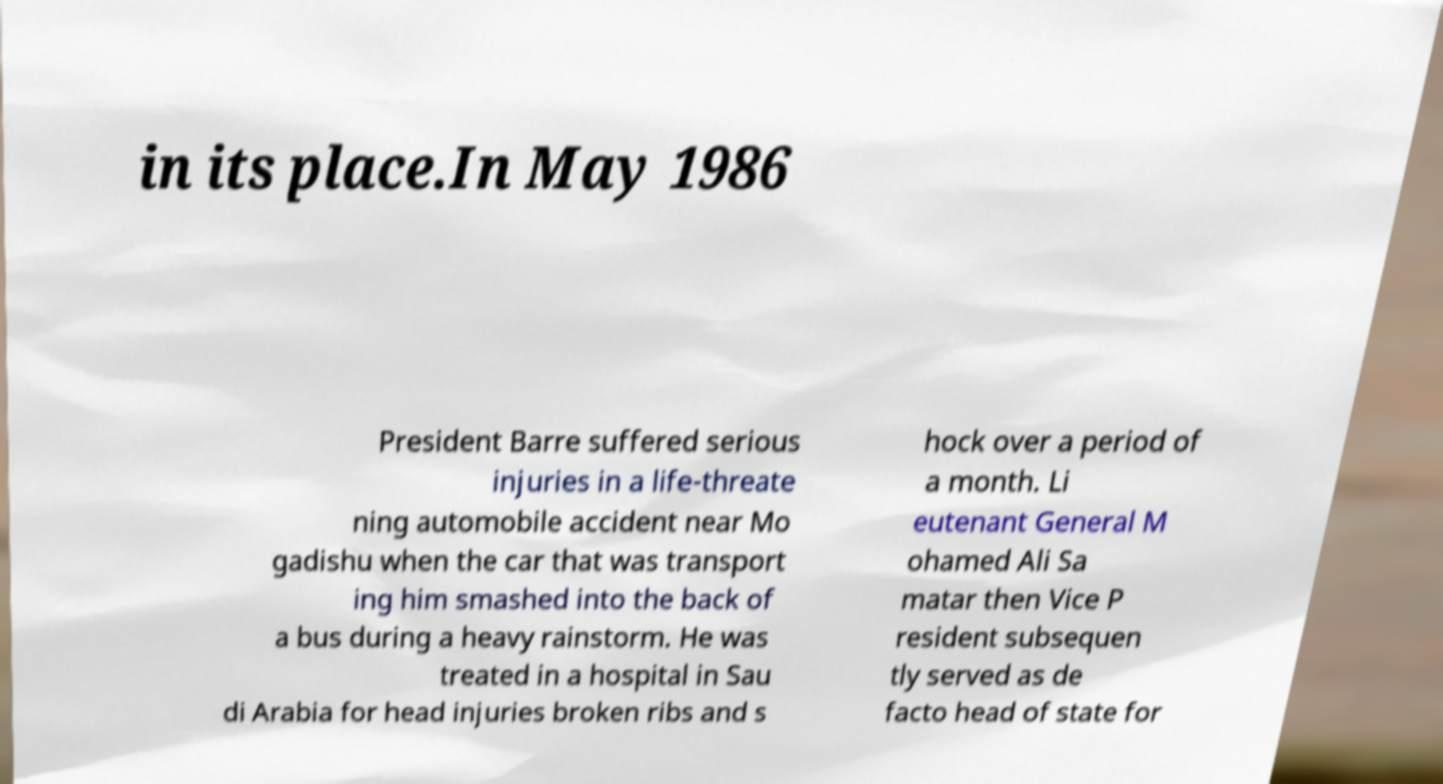Can you read and provide the text displayed in the image?This photo seems to have some interesting text. Can you extract and type it out for me? in its place.In May 1986 President Barre suffered serious injuries in a life-threate ning automobile accident near Mo gadishu when the car that was transport ing him smashed into the back of a bus during a heavy rainstorm. He was treated in a hospital in Sau di Arabia for head injuries broken ribs and s hock over a period of a month. Li eutenant General M ohamed Ali Sa matar then Vice P resident subsequen tly served as de facto head of state for 